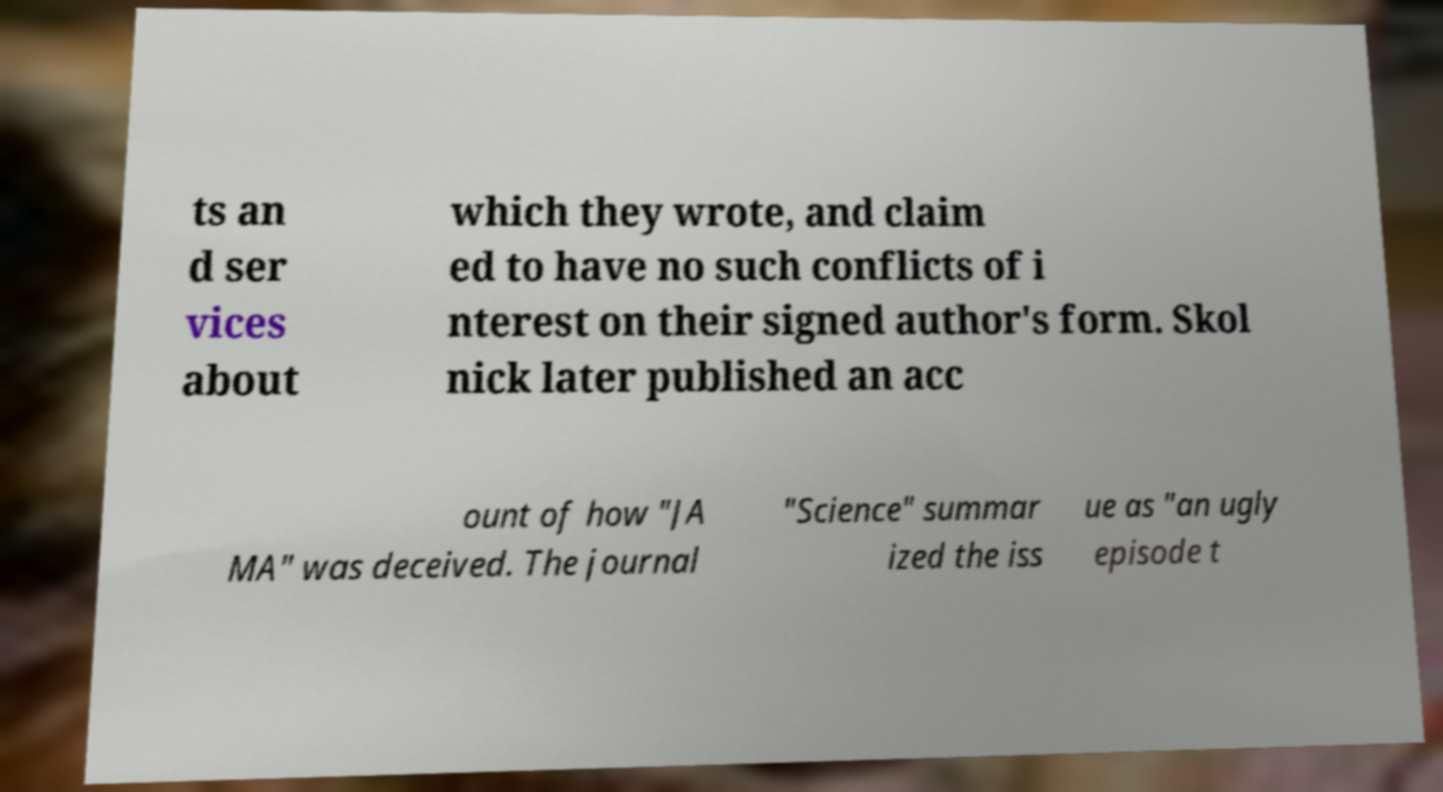There's text embedded in this image that I need extracted. Can you transcribe it verbatim? ts an d ser vices about which they wrote, and claim ed to have no such conflicts of i nterest on their signed author's form. Skol nick later published an acc ount of how "JA MA" was deceived. The journal "Science" summar ized the iss ue as "an ugly episode t 